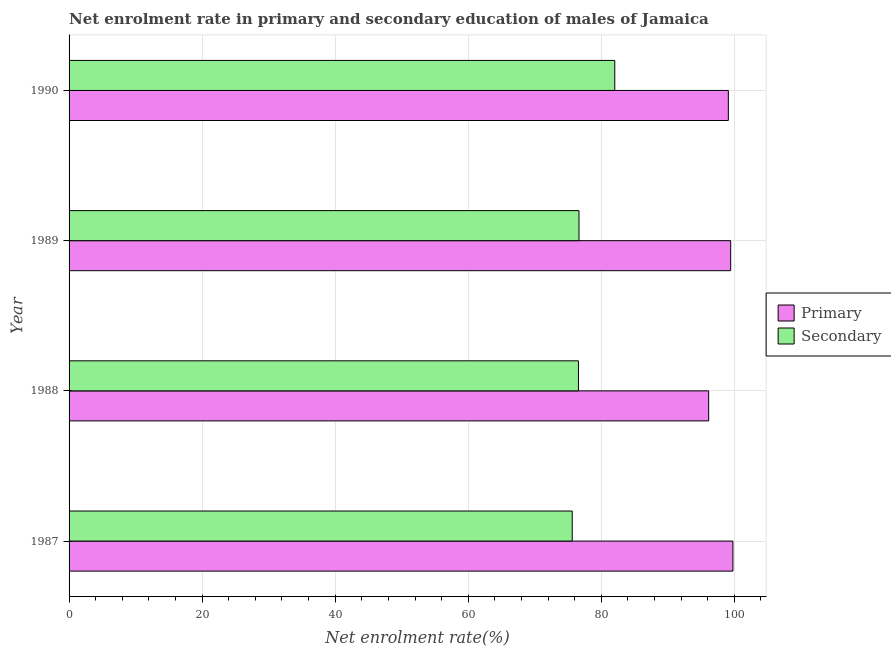How many different coloured bars are there?
Offer a very short reply. 2. Are the number of bars per tick equal to the number of legend labels?
Make the answer very short. Yes. How many bars are there on the 4th tick from the bottom?
Provide a succinct answer. 2. What is the enrollment rate in secondary education in 1988?
Offer a terse response. 76.57. Across all years, what is the maximum enrollment rate in primary education?
Keep it short and to the point. 99.79. Across all years, what is the minimum enrollment rate in primary education?
Provide a succinct answer. 96.14. In which year was the enrollment rate in secondary education maximum?
Your response must be concise. 1990. In which year was the enrollment rate in secondary education minimum?
Keep it short and to the point. 1987. What is the total enrollment rate in primary education in the graph?
Your answer should be very brief. 394.49. What is the difference between the enrollment rate in primary education in 1988 and that in 1989?
Offer a very short reply. -3.31. What is the difference between the enrollment rate in primary education in 1987 and the enrollment rate in secondary education in 1989?
Your answer should be compact. 23.14. What is the average enrollment rate in primary education per year?
Provide a short and direct response. 98.62. In the year 1988, what is the difference between the enrollment rate in primary education and enrollment rate in secondary education?
Make the answer very short. 19.57. In how many years, is the enrollment rate in secondary education greater than 88 %?
Provide a short and direct response. 0. What is the difference between the highest and the second highest enrollment rate in primary education?
Keep it short and to the point. 0.34. What is the difference between the highest and the lowest enrollment rate in primary education?
Provide a short and direct response. 3.65. In how many years, is the enrollment rate in primary education greater than the average enrollment rate in primary education taken over all years?
Provide a short and direct response. 3. What does the 2nd bar from the top in 1987 represents?
Keep it short and to the point. Primary. What does the 2nd bar from the bottom in 1990 represents?
Keep it short and to the point. Secondary. How many bars are there?
Make the answer very short. 8. Are all the bars in the graph horizontal?
Keep it short and to the point. Yes. What is the difference between two consecutive major ticks on the X-axis?
Provide a succinct answer. 20. Does the graph contain any zero values?
Provide a short and direct response. No. Where does the legend appear in the graph?
Provide a succinct answer. Center right. What is the title of the graph?
Make the answer very short. Net enrolment rate in primary and secondary education of males of Jamaica. What is the label or title of the X-axis?
Your answer should be very brief. Net enrolment rate(%). What is the Net enrolment rate(%) in Primary in 1987?
Provide a succinct answer. 99.79. What is the Net enrolment rate(%) of Secondary in 1987?
Provide a short and direct response. 75.63. What is the Net enrolment rate(%) of Primary in 1988?
Your answer should be very brief. 96.14. What is the Net enrolment rate(%) in Secondary in 1988?
Your answer should be compact. 76.57. What is the Net enrolment rate(%) of Primary in 1989?
Provide a succinct answer. 99.45. What is the Net enrolment rate(%) in Secondary in 1989?
Your answer should be very brief. 76.65. What is the Net enrolment rate(%) of Primary in 1990?
Your response must be concise. 99.1. What is the Net enrolment rate(%) of Secondary in 1990?
Offer a terse response. 82.03. Across all years, what is the maximum Net enrolment rate(%) in Primary?
Provide a succinct answer. 99.79. Across all years, what is the maximum Net enrolment rate(%) in Secondary?
Offer a very short reply. 82.03. Across all years, what is the minimum Net enrolment rate(%) in Primary?
Ensure brevity in your answer.  96.14. Across all years, what is the minimum Net enrolment rate(%) in Secondary?
Your answer should be compact. 75.63. What is the total Net enrolment rate(%) in Primary in the graph?
Offer a very short reply. 394.49. What is the total Net enrolment rate(%) in Secondary in the graph?
Your answer should be compact. 310.88. What is the difference between the Net enrolment rate(%) in Primary in 1987 and that in 1988?
Keep it short and to the point. 3.65. What is the difference between the Net enrolment rate(%) of Secondary in 1987 and that in 1988?
Provide a succinct answer. -0.94. What is the difference between the Net enrolment rate(%) of Primary in 1987 and that in 1989?
Offer a terse response. 0.34. What is the difference between the Net enrolment rate(%) of Secondary in 1987 and that in 1989?
Make the answer very short. -1.02. What is the difference between the Net enrolment rate(%) of Primary in 1987 and that in 1990?
Provide a short and direct response. 0.69. What is the difference between the Net enrolment rate(%) of Secondary in 1987 and that in 1990?
Provide a succinct answer. -6.39. What is the difference between the Net enrolment rate(%) in Primary in 1988 and that in 1989?
Your response must be concise. -3.31. What is the difference between the Net enrolment rate(%) of Secondary in 1988 and that in 1989?
Offer a terse response. -0.08. What is the difference between the Net enrolment rate(%) in Primary in 1988 and that in 1990?
Give a very brief answer. -2.96. What is the difference between the Net enrolment rate(%) of Secondary in 1988 and that in 1990?
Give a very brief answer. -5.46. What is the difference between the Net enrolment rate(%) of Primary in 1989 and that in 1990?
Keep it short and to the point. 0.35. What is the difference between the Net enrolment rate(%) of Secondary in 1989 and that in 1990?
Provide a succinct answer. -5.38. What is the difference between the Net enrolment rate(%) of Primary in 1987 and the Net enrolment rate(%) of Secondary in 1988?
Your answer should be very brief. 23.22. What is the difference between the Net enrolment rate(%) of Primary in 1987 and the Net enrolment rate(%) of Secondary in 1989?
Offer a terse response. 23.14. What is the difference between the Net enrolment rate(%) of Primary in 1987 and the Net enrolment rate(%) of Secondary in 1990?
Give a very brief answer. 17.76. What is the difference between the Net enrolment rate(%) in Primary in 1988 and the Net enrolment rate(%) in Secondary in 1989?
Keep it short and to the point. 19.49. What is the difference between the Net enrolment rate(%) of Primary in 1988 and the Net enrolment rate(%) of Secondary in 1990?
Give a very brief answer. 14.12. What is the difference between the Net enrolment rate(%) of Primary in 1989 and the Net enrolment rate(%) of Secondary in 1990?
Offer a very short reply. 17.42. What is the average Net enrolment rate(%) of Primary per year?
Ensure brevity in your answer.  98.62. What is the average Net enrolment rate(%) in Secondary per year?
Give a very brief answer. 77.72. In the year 1987, what is the difference between the Net enrolment rate(%) in Primary and Net enrolment rate(%) in Secondary?
Provide a short and direct response. 24.16. In the year 1988, what is the difference between the Net enrolment rate(%) of Primary and Net enrolment rate(%) of Secondary?
Make the answer very short. 19.57. In the year 1989, what is the difference between the Net enrolment rate(%) in Primary and Net enrolment rate(%) in Secondary?
Offer a terse response. 22.8. In the year 1990, what is the difference between the Net enrolment rate(%) in Primary and Net enrolment rate(%) in Secondary?
Give a very brief answer. 17.07. What is the ratio of the Net enrolment rate(%) of Primary in 1987 to that in 1988?
Keep it short and to the point. 1.04. What is the ratio of the Net enrolment rate(%) of Primary in 1987 to that in 1989?
Your answer should be compact. 1. What is the ratio of the Net enrolment rate(%) of Secondary in 1987 to that in 1989?
Provide a short and direct response. 0.99. What is the ratio of the Net enrolment rate(%) of Secondary in 1987 to that in 1990?
Ensure brevity in your answer.  0.92. What is the ratio of the Net enrolment rate(%) of Primary in 1988 to that in 1989?
Offer a terse response. 0.97. What is the ratio of the Net enrolment rate(%) in Primary in 1988 to that in 1990?
Your answer should be compact. 0.97. What is the ratio of the Net enrolment rate(%) of Secondary in 1988 to that in 1990?
Offer a terse response. 0.93. What is the ratio of the Net enrolment rate(%) of Primary in 1989 to that in 1990?
Give a very brief answer. 1. What is the ratio of the Net enrolment rate(%) of Secondary in 1989 to that in 1990?
Keep it short and to the point. 0.93. What is the difference between the highest and the second highest Net enrolment rate(%) of Primary?
Provide a succinct answer. 0.34. What is the difference between the highest and the second highest Net enrolment rate(%) of Secondary?
Offer a very short reply. 5.38. What is the difference between the highest and the lowest Net enrolment rate(%) in Primary?
Make the answer very short. 3.65. What is the difference between the highest and the lowest Net enrolment rate(%) in Secondary?
Your answer should be very brief. 6.39. 